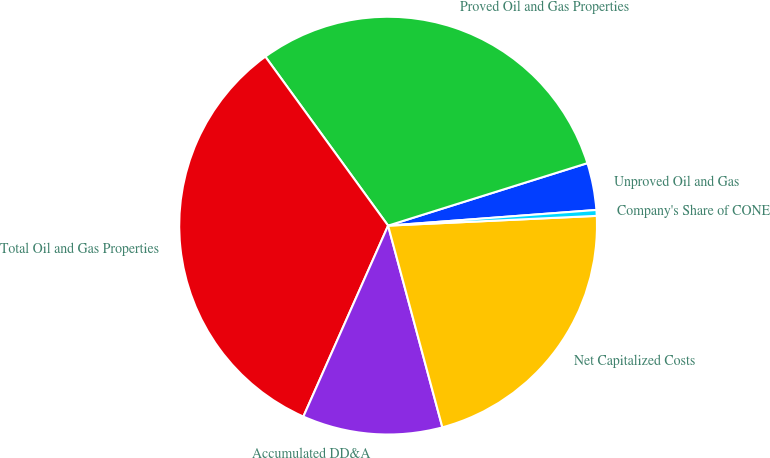Convert chart to OTSL. <chart><loc_0><loc_0><loc_500><loc_500><pie_chart><fcel>Unproved Oil and Gas<fcel>Proved Oil and Gas Properties<fcel>Total Oil and Gas Properties<fcel>Accumulated DD&A<fcel>Net Capitalized Costs<fcel>Company's Share of CONE<nl><fcel>3.64%<fcel>30.16%<fcel>33.35%<fcel>10.83%<fcel>21.56%<fcel>0.45%<nl></chart> 